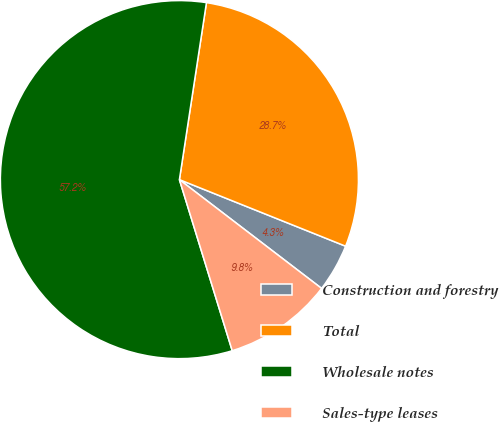<chart> <loc_0><loc_0><loc_500><loc_500><pie_chart><fcel>Construction and forestry<fcel>Total<fcel>Wholesale notes<fcel>Sales-type leases<nl><fcel>4.33%<fcel>28.65%<fcel>57.18%<fcel>9.84%<nl></chart> 